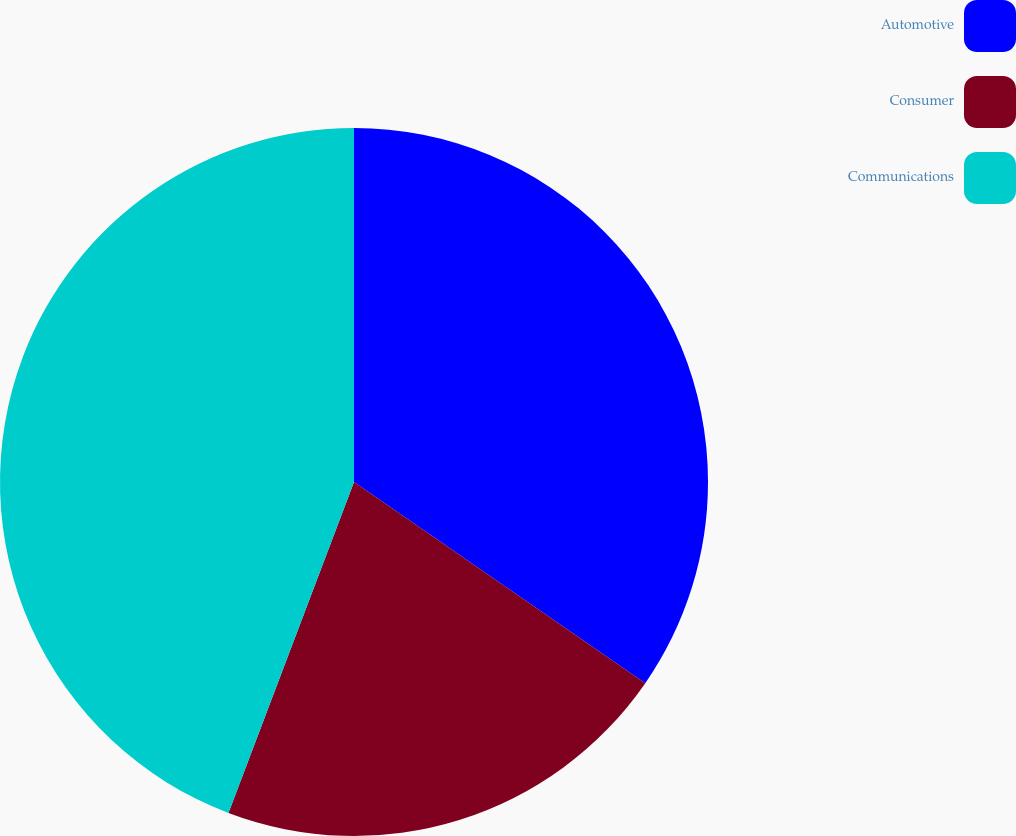Convert chart to OTSL. <chart><loc_0><loc_0><loc_500><loc_500><pie_chart><fcel>Automotive<fcel>Consumer<fcel>Communications<nl><fcel>34.62%<fcel>21.15%<fcel>44.23%<nl></chart> 